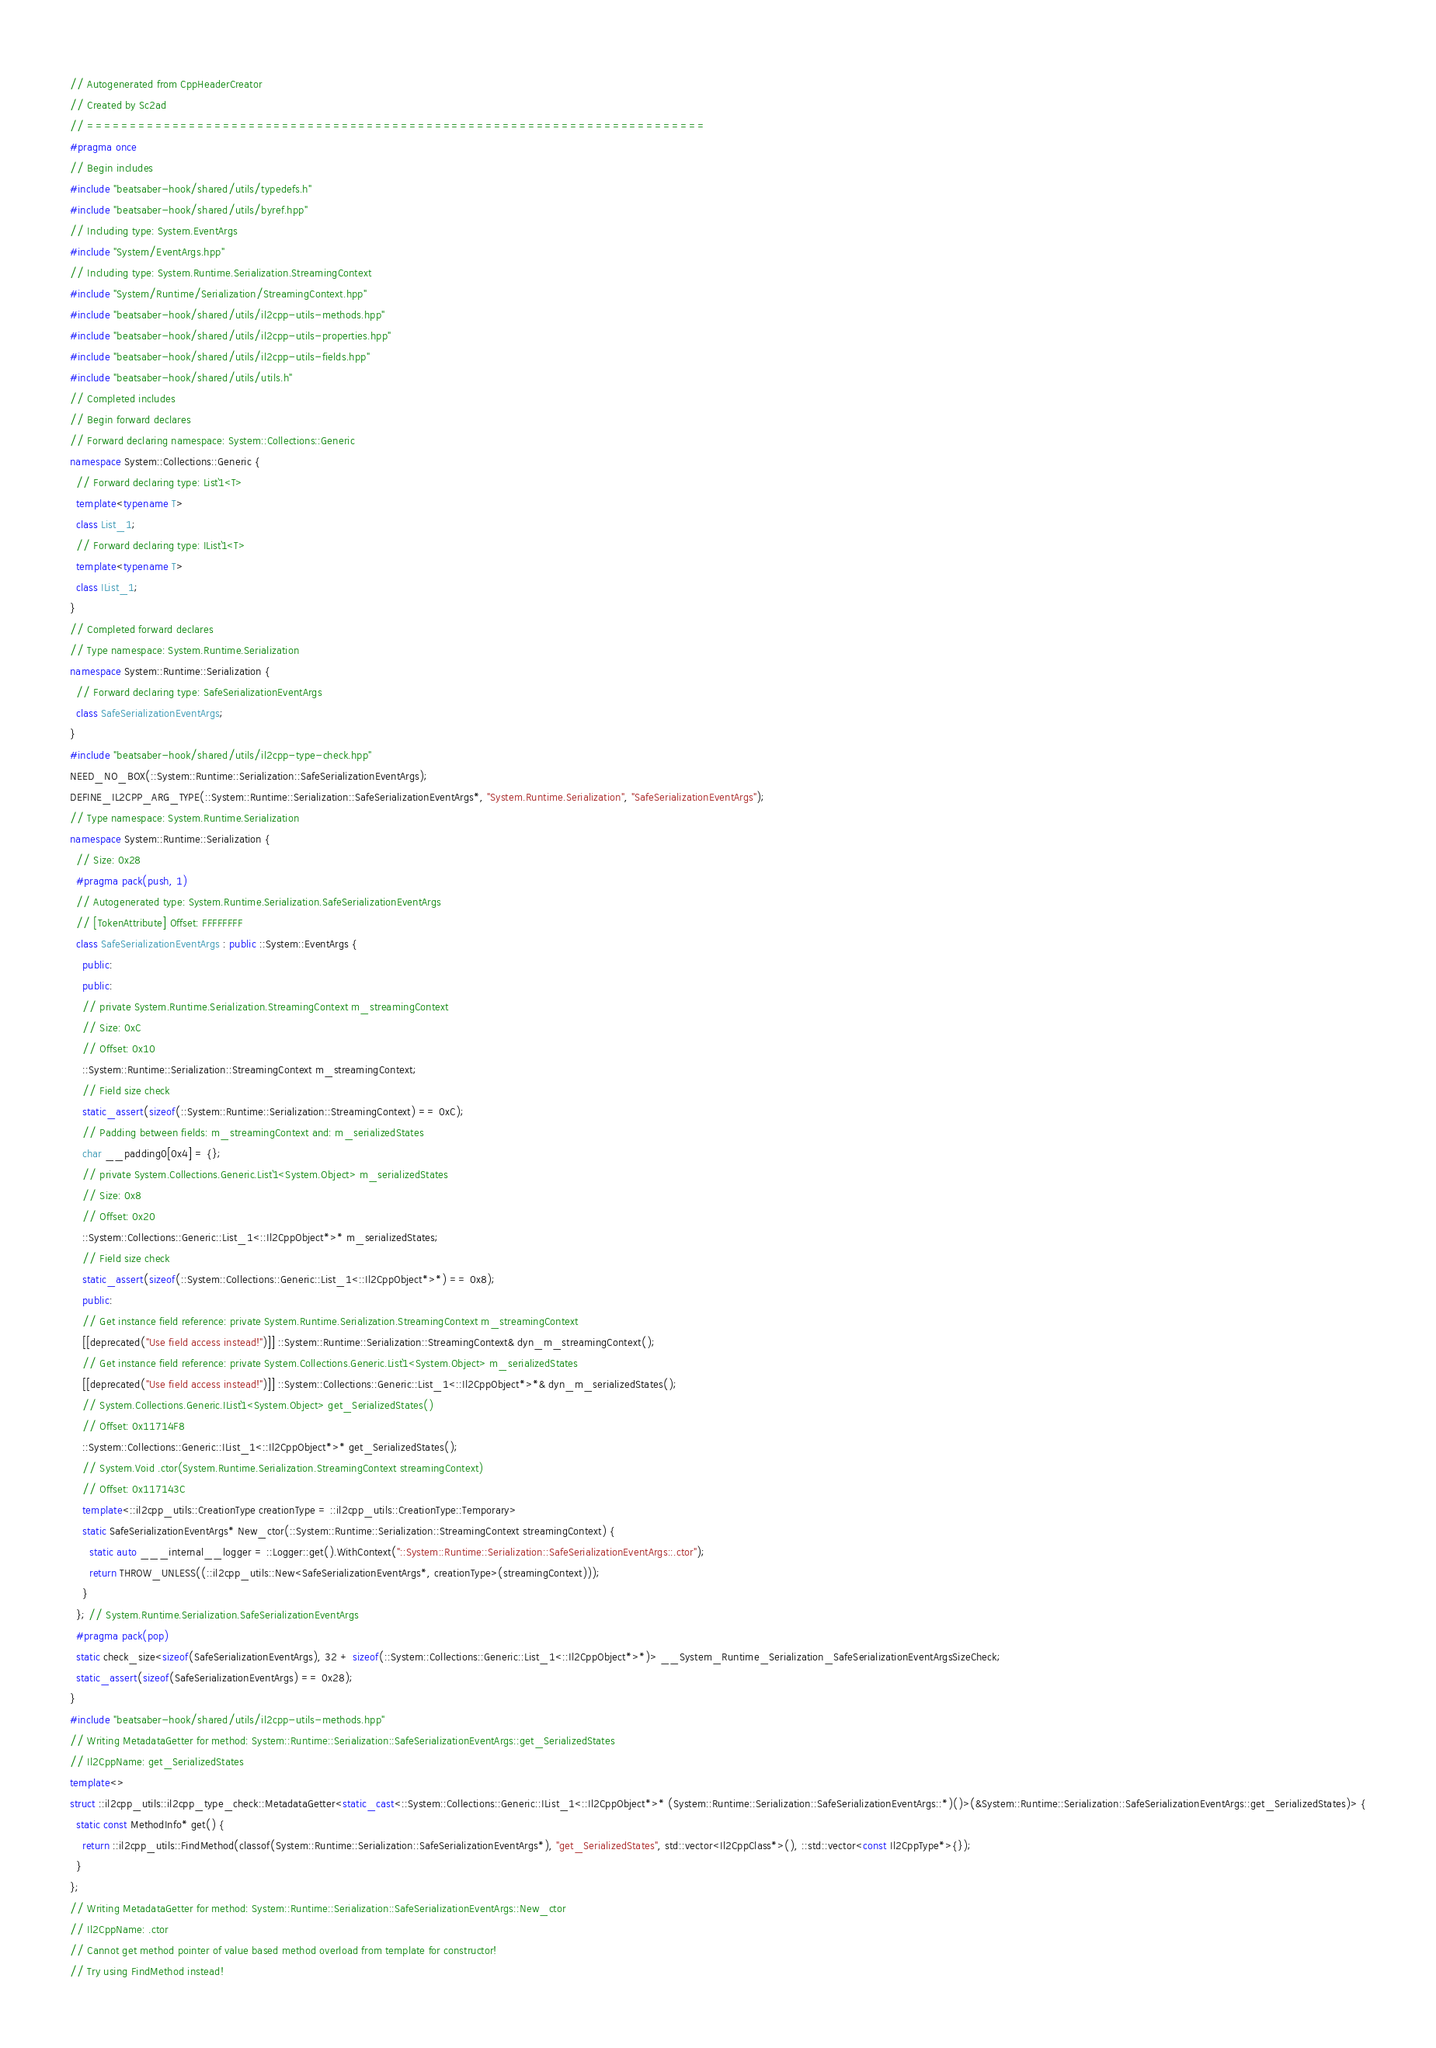<code> <loc_0><loc_0><loc_500><loc_500><_C++_>// Autogenerated from CppHeaderCreator
// Created by Sc2ad
// =========================================================================
#pragma once
// Begin includes
#include "beatsaber-hook/shared/utils/typedefs.h"
#include "beatsaber-hook/shared/utils/byref.hpp"
// Including type: System.EventArgs
#include "System/EventArgs.hpp"
// Including type: System.Runtime.Serialization.StreamingContext
#include "System/Runtime/Serialization/StreamingContext.hpp"
#include "beatsaber-hook/shared/utils/il2cpp-utils-methods.hpp"
#include "beatsaber-hook/shared/utils/il2cpp-utils-properties.hpp"
#include "beatsaber-hook/shared/utils/il2cpp-utils-fields.hpp"
#include "beatsaber-hook/shared/utils/utils.h"
// Completed includes
// Begin forward declares
// Forward declaring namespace: System::Collections::Generic
namespace System::Collections::Generic {
  // Forward declaring type: List`1<T>
  template<typename T>
  class List_1;
  // Forward declaring type: IList`1<T>
  template<typename T>
  class IList_1;
}
// Completed forward declares
// Type namespace: System.Runtime.Serialization
namespace System::Runtime::Serialization {
  // Forward declaring type: SafeSerializationEventArgs
  class SafeSerializationEventArgs;
}
#include "beatsaber-hook/shared/utils/il2cpp-type-check.hpp"
NEED_NO_BOX(::System::Runtime::Serialization::SafeSerializationEventArgs);
DEFINE_IL2CPP_ARG_TYPE(::System::Runtime::Serialization::SafeSerializationEventArgs*, "System.Runtime.Serialization", "SafeSerializationEventArgs");
// Type namespace: System.Runtime.Serialization
namespace System::Runtime::Serialization {
  // Size: 0x28
  #pragma pack(push, 1)
  // Autogenerated type: System.Runtime.Serialization.SafeSerializationEventArgs
  // [TokenAttribute] Offset: FFFFFFFF
  class SafeSerializationEventArgs : public ::System::EventArgs {
    public:
    public:
    // private System.Runtime.Serialization.StreamingContext m_streamingContext
    // Size: 0xC
    // Offset: 0x10
    ::System::Runtime::Serialization::StreamingContext m_streamingContext;
    // Field size check
    static_assert(sizeof(::System::Runtime::Serialization::StreamingContext) == 0xC);
    // Padding between fields: m_streamingContext and: m_serializedStates
    char __padding0[0x4] = {};
    // private System.Collections.Generic.List`1<System.Object> m_serializedStates
    // Size: 0x8
    // Offset: 0x20
    ::System::Collections::Generic::List_1<::Il2CppObject*>* m_serializedStates;
    // Field size check
    static_assert(sizeof(::System::Collections::Generic::List_1<::Il2CppObject*>*) == 0x8);
    public:
    // Get instance field reference: private System.Runtime.Serialization.StreamingContext m_streamingContext
    [[deprecated("Use field access instead!")]] ::System::Runtime::Serialization::StreamingContext& dyn_m_streamingContext();
    // Get instance field reference: private System.Collections.Generic.List`1<System.Object> m_serializedStates
    [[deprecated("Use field access instead!")]] ::System::Collections::Generic::List_1<::Il2CppObject*>*& dyn_m_serializedStates();
    // System.Collections.Generic.IList`1<System.Object> get_SerializedStates()
    // Offset: 0x11714F8
    ::System::Collections::Generic::IList_1<::Il2CppObject*>* get_SerializedStates();
    // System.Void .ctor(System.Runtime.Serialization.StreamingContext streamingContext)
    // Offset: 0x117143C
    template<::il2cpp_utils::CreationType creationType = ::il2cpp_utils::CreationType::Temporary>
    static SafeSerializationEventArgs* New_ctor(::System::Runtime::Serialization::StreamingContext streamingContext) {
      static auto ___internal__logger = ::Logger::get().WithContext("::System::Runtime::Serialization::SafeSerializationEventArgs::.ctor");
      return THROW_UNLESS((::il2cpp_utils::New<SafeSerializationEventArgs*, creationType>(streamingContext)));
    }
  }; // System.Runtime.Serialization.SafeSerializationEventArgs
  #pragma pack(pop)
  static check_size<sizeof(SafeSerializationEventArgs), 32 + sizeof(::System::Collections::Generic::List_1<::Il2CppObject*>*)> __System_Runtime_Serialization_SafeSerializationEventArgsSizeCheck;
  static_assert(sizeof(SafeSerializationEventArgs) == 0x28);
}
#include "beatsaber-hook/shared/utils/il2cpp-utils-methods.hpp"
// Writing MetadataGetter for method: System::Runtime::Serialization::SafeSerializationEventArgs::get_SerializedStates
// Il2CppName: get_SerializedStates
template<>
struct ::il2cpp_utils::il2cpp_type_check::MetadataGetter<static_cast<::System::Collections::Generic::IList_1<::Il2CppObject*>* (System::Runtime::Serialization::SafeSerializationEventArgs::*)()>(&System::Runtime::Serialization::SafeSerializationEventArgs::get_SerializedStates)> {
  static const MethodInfo* get() {
    return ::il2cpp_utils::FindMethod(classof(System::Runtime::Serialization::SafeSerializationEventArgs*), "get_SerializedStates", std::vector<Il2CppClass*>(), ::std::vector<const Il2CppType*>{});
  }
};
// Writing MetadataGetter for method: System::Runtime::Serialization::SafeSerializationEventArgs::New_ctor
// Il2CppName: .ctor
// Cannot get method pointer of value based method overload from template for constructor!
// Try using FindMethod instead!
</code> 